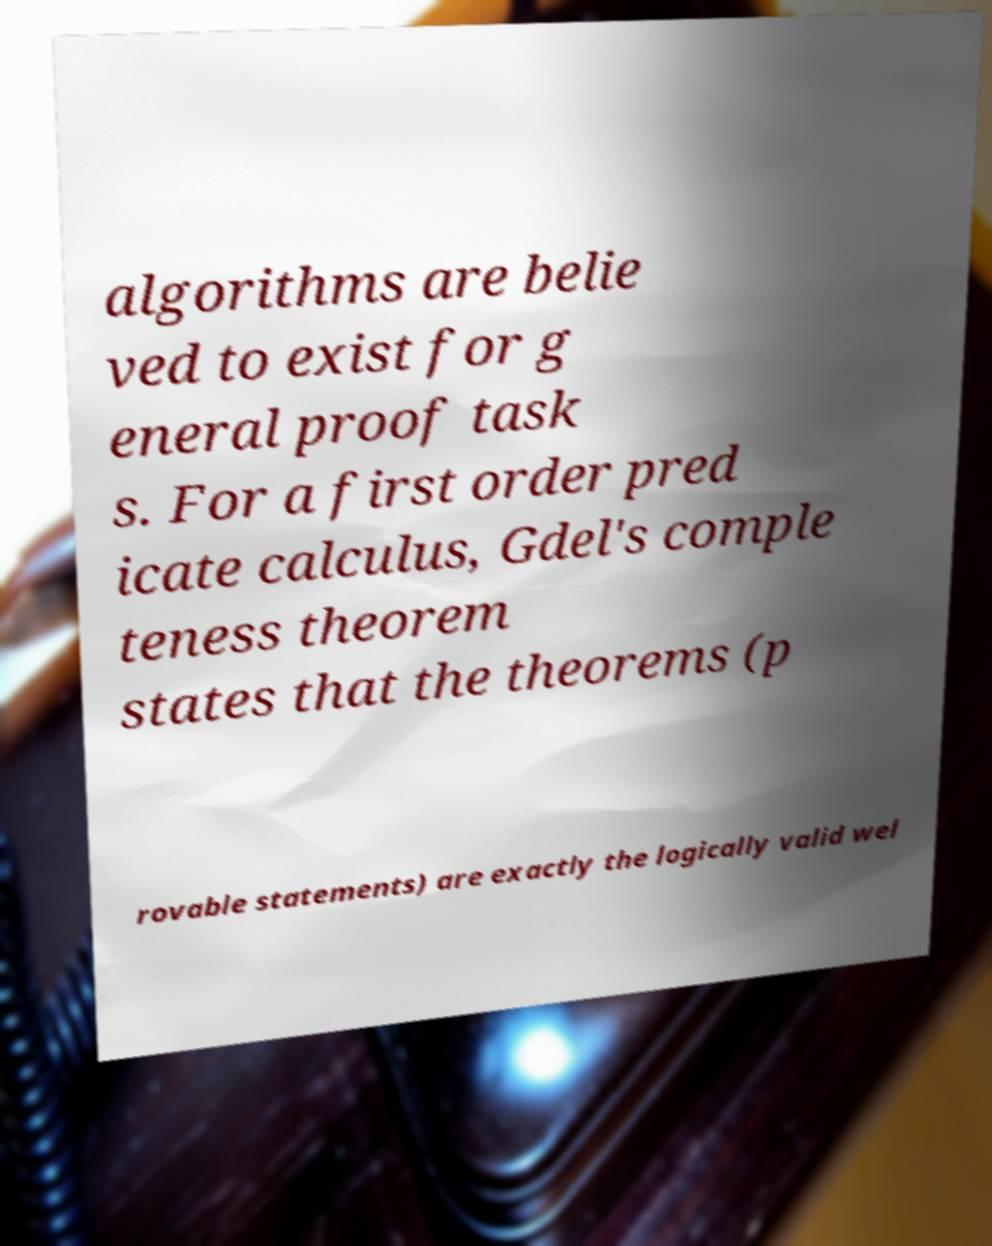Please identify and transcribe the text found in this image. algorithms are belie ved to exist for g eneral proof task s. For a first order pred icate calculus, Gdel's comple teness theorem states that the theorems (p rovable statements) are exactly the logically valid wel 